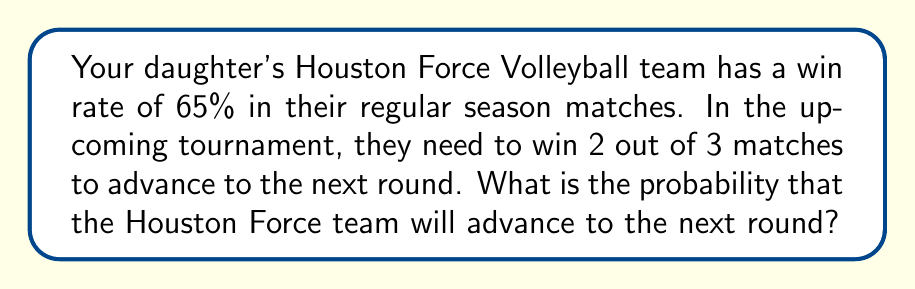Show me your answer to this math problem. Let's approach this step-by-step:

1) First, we need to identify the possible ways the team can advance:
   - Win first two matches (WW)
   - Win first and third matches (WLW)
   - Win second and third matches (LWW)

2) The probability of winning a single match is 0.65 (65%)
   The probability of losing a single match is 1 - 0.65 = 0.35 (35%)

3) Now, let's calculate the probability of each scenario:

   P(WW) = $0.65 \times 0.65 = 0.4225$
   P(WLW) = $0.65 \times 0.35 \times 0.65 = 0.148525$
   P(LWW) = $0.35 \times 0.65 \times 0.65 = 0.148525$

4) The total probability of advancing is the sum of these probabilities:

   P(advancing) = P(WW) + P(WLW) + P(LWW)
                = $0.4225 + 0.148525 + 0.148525$
                = $0.71955$

5) Convert to a percentage:
   $0.71955 \times 100\% = 71.955\%$

Therefore, the probability that the Houston Force team will advance to the next round is approximately 71.96%.
Answer: $71.96\%$ 